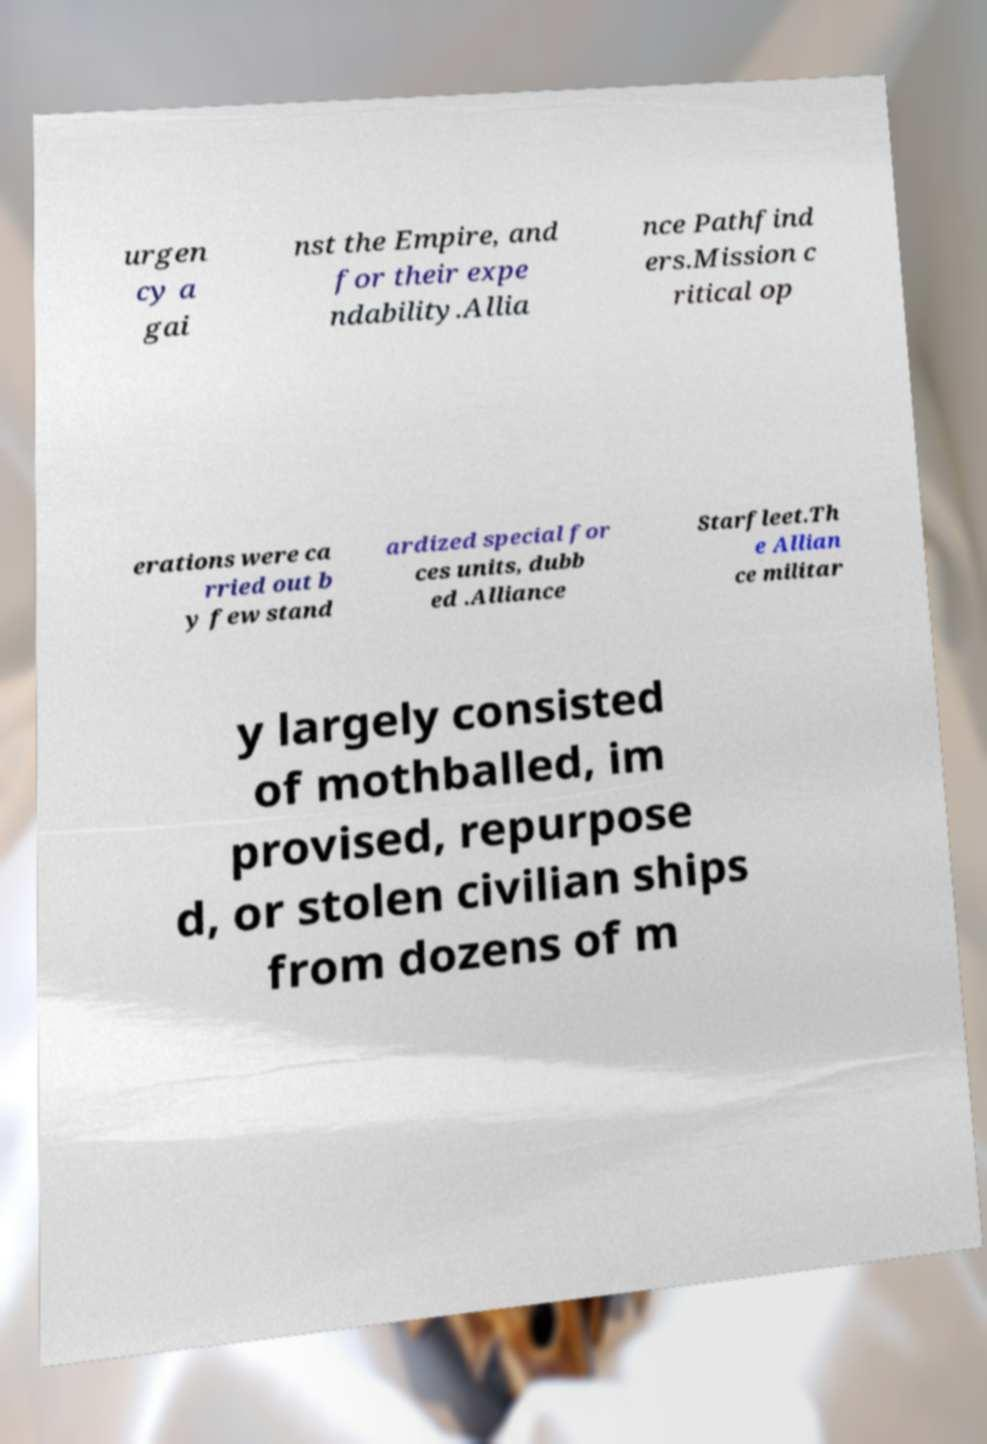There's text embedded in this image that I need extracted. Can you transcribe it verbatim? urgen cy a gai nst the Empire, and for their expe ndability.Allia nce Pathfind ers.Mission c ritical op erations were ca rried out b y few stand ardized special for ces units, dubb ed .Alliance Starfleet.Th e Allian ce militar y largely consisted of mothballed, im provised, repurpose d, or stolen civilian ships from dozens of m 